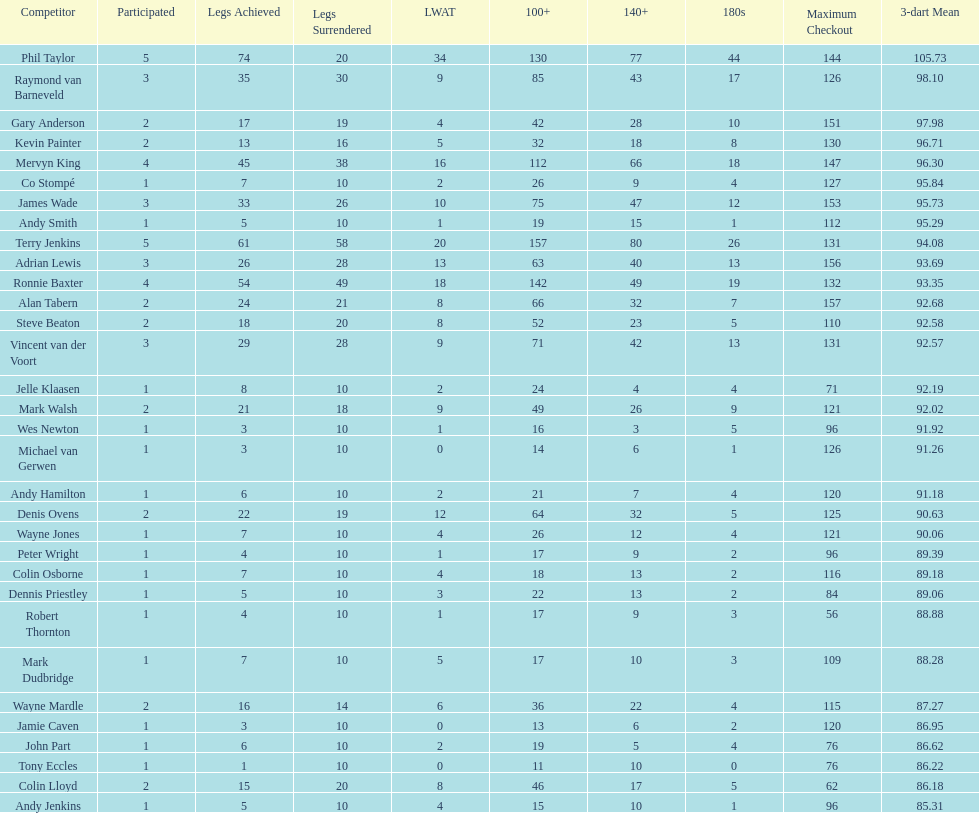What is the overall count of players who have played more than 3 games? 4. 